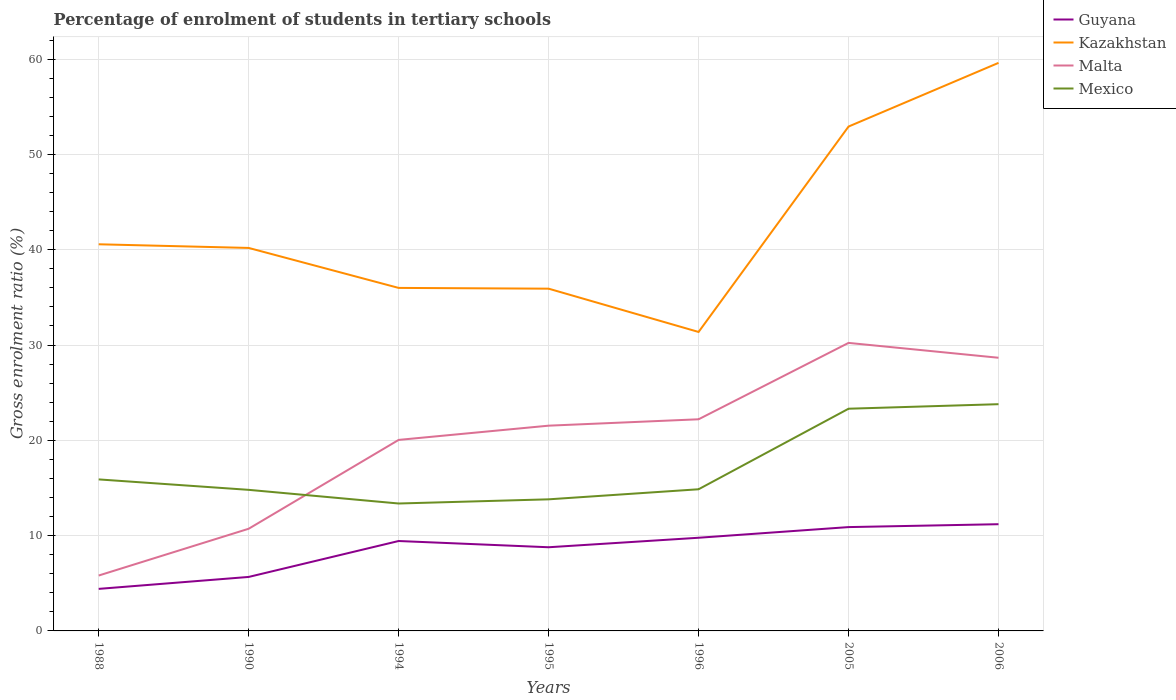Is the number of lines equal to the number of legend labels?
Your answer should be very brief. Yes. Across all years, what is the maximum percentage of students enrolled in tertiary schools in Guyana?
Offer a terse response. 4.41. In which year was the percentage of students enrolled in tertiary schools in Kazakhstan maximum?
Ensure brevity in your answer.  1996. What is the total percentage of students enrolled in tertiary schools in Guyana in the graph?
Your response must be concise. -5.53. What is the difference between the highest and the second highest percentage of students enrolled in tertiary schools in Kazakhstan?
Give a very brief answer. 28.24. What is the difference between the highest and the lowest percentage of students enrolled in tertiary schools in Malta?
Offer a very short reply. 5. How many lines are there?
Keep it short and to the point. 4. How many years are there in the graph?
Your answer should be compact. 7. Does the graph contain grids?
Your answer should be compact. Yes. What is the title of the graph?
Your answer should be very brief. Percentage of enrolment of students in tertiary schools. Does "Namibia" appear as one of the legend labels in the graph?
Your answer should be very brief. No. What is the label or title of the X-axis?
Give a very brief answer. Years. What is the label or title of the Y-axis?
Ensure brevity in your answer.  Gross enrolment ratio (%). What is the Gross enrolment ratio (%) of Guyana in 1988?
Provide a succinct answer. 4.41. What is the Gross enrolment ratio (%) in Kazakhstan in 1988?
Your answer should be compact. 40.57. What is the Gross enrolment ratio (%) in Malta in 1988?
Provide a short and direct response. 5.81. What is the Gross enrolment ratio (%) of Mexico in 1988?
Keep it short and to the point. 15.9. What is the Gross enrolment ratio (%) of Guyana in 1990?
Provide a short and direct response. 5.66. What is the Gross enrolment ratio (%) of Kazakhstan in 1990?
Your answer should be very brief. 40.19. What is the Gross enrolment ratio (%) of Malta in 1990?
Make the answer very short. 10.72. What is the Gross enrolment ratio (%) of Mexico in 1990?
Offer a very short reply. 14.8. What is the Gross enrolment ratio (%) of Guyana in 1994?
Your answer should be compact. 9.43. What is the Gross enrolment ratio (%) of Kazakhstan in 1994?
Offer a terse response. 35.99. What is the Gross enrolment ratio (%) in Malta in 1994?
Give a very brief answer. 20.04. What is the Gross enrolment ratio (%) of Mexico in 1994?
Your response must be concise. 13.37. What is the Gross enrolment ratio (%) in Guyana in 1995?
Offer a terse response. 8.78. What is the Gross enrolment ratio (%) in Kazakhstan in 1995?
Offer a terse response. 35.91. What is the Gross enrolment ratio (%) in Malta in 1995?
Make the answer very short. 21.54. What is the Gross enrolment ratio (%) of Mexico in 1995?
Provide a succinct answer. 13.81. What is the Gross enrolment ratio (%) in Guyana in 1996?
Keep it short and to the point. 9.78. What is the Gross enrolment ratio (%) of Kazakhstan in 1996?
Offer a very short reply. 31.37. What is the Gross enrolment ratio (%) of Malta in 1996?
Your answer should be very brief. 22.21. What is the Gross enrolment ratio (%) in Mexico in 1996?
Make the answer very short. 14.86. What is the Gross enrolment ratio (%) in Guyana in 2005?
Your answer should be very brief. 10.89. What is the Gross enrolment ratio (%) of Kazakhstan in 2005?
Keep it short and to the point. 52.92. What is the Gross enrolment ratio (%) in Malta in 2005?
Ensure brevity in your answer.  30.22. What is the Gross enrolment ratio (%) of Mexico in 2005?
Give a very brief answer. 23.31. What is the Gross enrolment ratio (%) of Guyana in 2006?
Provide a short and direct response. 11.2. What is the Gross enrolment ratio (%) in Kazakhstan in 2006?
Your response must be concise. 59.6. What is the Gross enrolment ratio (%) of Malta in 2006?
Make the answer very short. 28.66. What is the Gross enrolment ratio (%) in Mexico in 2006?
Give a very brief answer. 23.79. Across all years, what is the maximum Gross enrolment ratio (%) of Guyana?
Keep it short and to the point. 11.2. Across all years, what is the maximum Gross enrolment ratio (%) in Kazakhstan?
Keep it short and to the point. 59.6. Across all years, what is the maximum Gross enrolment ratio (%) in Malta?
Your response must be concise. 30.22. Across all years, what is the maximum Gross enrolment ratio (%) in Mexico?
Ensure brevity in your answer.  23.79. Across all years, what is the minimum Gross enrolment ratio (%) of Guyana?
Give a very brief answer. 4.41. Across all years, what is the minimum Gross enrolment ratio (%) of Kazakhstan?
Offer a very short reply. 31.37. Across all years, what is the minimum Gross enrolment ratio (%) in Malta?
Your response must be concise. 5.81. Across all years, what is the minimum Gross enrolment ratio (%) in Mexico?
Give a very brief answer. 13.37. What is the total Gross enrolment ratio (%) in Guyana in the graph?
Give a very brief answer. 60.16. What is the total Gross enrolment ratio (%) of Kazakhstan in the graph?
Your answer should be compact. 296.55. What is the total Gross enrolment ratio (%) in Malta in the graph?
Your response must be concise. 139.2. What is the total Gross enrolment ratio (%) in Mexico in the graph?
Your answer should be compact. 119.85. What is the difference between the Gross enrolment ratio (%) in Guyana in 1988 and that in 1990?
Ensure brevity in your answer.  -1.25. What is the difference between the Gross enrolment ratio (%) in Kazakhstan in 1988 and that in 1990?
Your response must be concise. 0.38. What is the difference between the Gross enrolment ratio (%) of Malta in 1988 and that in 1990?
Provide a short and direct response. -4.91. What is the difference between the Gross enrolment ratio (%) of Mexico in 1988 and that in 1990?
Provide a short and direct response. 1.1. What is the difference between the Gross enrolment ratio (%) of Guyana in 1988 and that in 1994?
Offer a terse response. -5.02. What is the difference between the Gross enrolment ratio (%) in Kazakhstan in 1988 and that in 1994?
Your answer should be very brief. 4.58. What is the difference between the Gross enrolment ratio (%) of Malta in 1988 and that in 1994?
Offer a terse response. -14.23. What is the difference between the Gross enrolment ratio (%) of Mexico in 1988 and that in 1994?
Keep it short and to the point. 2.53. What is the difference between the Gross enrolment ratio (%) in Guyana in 1988 and that in 1995?
Keep it short and to the point. -4.37. What is the difference between the Gross enrolment ratio (%) of Kazakhstan in 1988 and that in 1995?
Provide a succinct answer. 4.66. What is the difference between the Gross enrolment ratio (%) in Malta in 1988 and that in 1995?
Make the answer very short. -15.72. What is the difference between the Gross enrolment ratio (%) of Mexico in 1988 and that in 1995?
Provide a succinct answer. 2.09. What is the difference between the Gross enrolment ratio (%) of Guyana in 1988 and that in 1996?
Provide a short and direct response. -5.36. What is the difference between the Gross enrolment ratio (%) of Kazakhstan in 1988 and that in 1996?
Offer a very short reply. 9.2. What is the difference between the Gross enrolment ratio (%) of Malta in 1988 and that in 1996?
Offer a terse response. -16.39. What is the difference between the Gross enrolment ratio (%) in Mexico in 1988 and that in 1996?
Make the answer very short. 1.03. What is the difference between the Gross enrolment ratio (%) in Guyana in 1988 and that in 2005?
Ensure brevity in your answer.  -6.48. What is the difference between the Gross enrolment ratio (%) in Kazakhstan in 1988 and that in 2005?
Offer a very short reply. -12.35. What is the difference between the Gross enrolment ratio (%) of Malta in 1988 and that in 2005?
Your response must be concise. -24.41. What is the difference between the Gross enrolment ratio (%) of Mexico in 1988 and that in 2005?
Your answer should be compact. -7.42. What is the difference between the Gross enrolment ratio (%) of Guyana in 1988 and that in 2006?
Your response must be concise. -6.79. What is the difference between the Gross enrolment ratio (%) in Kazakhstan in 1988 and that in 2006?
Give a very brief answer. -19.04. What is the difference between the Gross enrolment ratio (%) in Malta in 1988 and that in 2006?
Ensure brevity in your answer.  -22.85. What is the difference between the Gross enrolment ratio (%) of Mexico in 1988 and that in 2006?
Ensure brevity in your answer.  -7.89. What is the difference between the Gross enrolment ratio (%) of Guyana in 1990 and that in 1994?
Your answer should be very brief. -3.77. What is the difference between the Gross enrolment ratio (%) in Kazakhstan in 1990 and that in 1994?
Keep it short and to the point. 4.2. What is the difference between the Gross enrolment ratio (%) of Malta in 1990 and that in 1994?
Your answer should be very brief. -9.32. What is the difference between the Gross enrolment ratio (%) in Mexico in 1990 and that in 1994?
Make the answer very short. 1.43. What is the difference between the Gross enrolment ratio (%) in Guyana in 1990 and that in 1995?
Provide a short and direct response. -3.11. What is the difference between the Gross enrolment ratio (%) in Kazakhstan in 1990 and that in 1995?
Offer a terse response. 4.27. What is the difference between the Gross enrolment ratio (%) of Malta in 1990 and that in 1995?
Keep it short and to the point. -10.82. What is the difference between the Gross enrolment ratio (%) in Guyana in 1990 and that in 1996?
Provide a short and direct response. -4.11. What is the difference between the Gross enrolment ratio (%) of Kazakhstan in 1990 and that in 1996?
Provide a succinct answer. 8.82. What is the difference between the Gross enrolment ratio (%) in Malta in 1990 and that in 1996?
Provide a succinct answer. -11.49. What is the difference between the Gross enrolment ratio (%) of Mexico in 1990 and that in 1996?
Keep it short and to the point. -0.06. What is the difference between the Gross enrolment ratio (%) of Guyana in 1990 and that in 2005?
Make the answer very short. -5.23. What is the difference between the Gross enrolment ratio (%) of Kazakhstan in 1990 and that in 2005?
Offer a terse response. -12.74. What is the difference between the Gross enrolment ratio (%) in Malta in 1990 and that in 2005?
Provide a short and direct response. -19.5. What is the difference between the Gross enrolment ratio (%) of Mexico in 1990 and that in 2005?
Offer a terse response. -8.51. What is the difference between the Gross enrolment ratio (%) in Guyana in 1990 and that in 2006?
Offer a very short reply. -5.53. What is the difference between the Gross enrolment ratio (%) in Kazakhstan in 1990 and that in 2006?
Offer a terse response. -19.42. What is the difference between the Gross enrolment ratio (%) of Malta in 1990 and that in 2006?
Provide a short and direct response. -17.94. What is the difference between the Gross enrolment ratio (%) of Mexico in 1990 and that in 2006?
Offer a terse response. -8.99. What is the difference between the Gross enrolment ratio (%) of Guyana in 1994 and that in 1995?
Offer a terse response. 0.65. What is the difference between the Gross enrolment ratio (%) of Kazakhstan in 1994 and that in 1995?
Your answer should be very brief. 0.08. What is the difference between the Gross enrolment ratio (%) in Malta in 1994 and that in 1995?
Make the answer very short. -1.49. What is the difference between the Gross enrolment ratio (%) of Mexico in 1994 and that in 1995?
Make the answer very short. -0.44. What is the difference between the Gross enrolment ratio (%) in Guyana in 1994 and that in 1996?
Offer a very short reply. -0.34. What is the difference between the Gross enrolment ratio (%) in Kazakhstan in 1994 and that in 1996?
Offer a very short reply. 4.62. What is the difference between the Gross enrolment ratio (%) of Malta in 1994 and that in 1996?
Keep it short and to the point. -2.16. What is the difference between the Gross enrolment ratio (%) of Mexico in 1994 and that in 1996?
Your answer should be very brief. -1.49. What is the difference between the Gross enrolment ratio (%) of Guyana in 1994 and that in 2005?
Your answer should be compact. -1.46. What is the difference between the Gross enrolment ratio (%) in Kazakhstan in 1994 and that in 2005?
Your answer should be very brief. -16.93. What is the difference between the Gross enrolment ratio (%) of Malta in 1994 and that in 2005?
Make the answer very short. -10.18. What is the difference between the Gross enrolment ratio (%) of Mexico in 1994 and that in 2005?
Your answer should be compact. -9.94. What is the difference between the Gross enrolment ratio (%) of Guyana in 1994 and that in 2006?
Your response must be concise. -1.76. What is the difference between the Gross enrolment ratio (%) in Kazakhstan in 1994 and that in 2006?
Give a very brief answer. -23.61. What is the difference between the Gross enrolment ratio (%) of Malta in 1994 and that in 2006?
Keep it short and to the point. -8.62. What is the difference between the Gross enrolment ratio (%) in Mexico in 1994 and that in 2006?
Give a very brief answer. -10.42. What is the difference between the Gross enrolment ratio (%) of Guyana in 1995 and that in 1996?
Provide a short and direct response. -1. What is the difference between the Gross enrolment ratio (%) of Kazakhstan in 1995 and that in 1996?
Make the answer very short. 4.54. What is the difference between the Gross enrolment ratio (%) in Malta in 1995 and that in 1996?
Your answer should be compact. -0.67. What is the difference between the Gross enrolment ratio (%) in Mexico in 1995 and that in 1996?
Offer a terse response. -1.06. What is the difference between the Gross enrolment ratio (%) of Guyana in 1995 and that in 2005?
Offer a terse response. -2.11. What is the difference between the Gross enrolment ratio (%) in Kazakhstan in 1995 and that in 2005?
Keep it short and to the point. -17.01. What is the difference between the Gross enrolment ratio (%) in Malta in 1995 and that in 2005?
Give a very brief answer. -8.69. What is the difference between the Gross enrolment ratio (%) of Mexico in 1995 and that in 2005?
Keep it short and to the point. -9.51. What is the difference between the Gross enrolment ratio (%) of Guyana in 1995 and that in 2006?
Your answer should be compact. -2.42. What is the difference between the Gross enrolment ratio (%) of Kazakhstan in 1995 and that in 2006?
Provide a succinct answer. -23.69. What is the difference between the Gross enrolment ratio (%) of Malta in 1995 and that in 2006?
Offer a very short reply. -7.13. What is the difference between the Gross enrolment ratio (%) in Mexico in 1995 and that in 2006?
Provide a short and direct response. -9.98. What is the difference between the Gross enrolment ratio (%) of Guyana in 1996 and that in 2005?
Provide a short and direct response. -1.12. What is the difference between the Gross enrolment ratio (%) of Kazakhstan in 1996 and that in 2005?
Provide a short and direct response. -21.55. What is the difference between the Gross enrolment ratio (%) of Malta in 1996 and that in 2005?
Offer a very short reply. -8.02. What is the difference between the Gross enrolment ratio (%) in Mexico in 1996 and that in 2005?
Ensure brevity in your answer.  -8.45. What is the difference between the Gross enrolment ratio (%) of Guyana in 1996 and that in 2006?
Provide a short and direct response. -1.42. What is the difference between the Gross enrolment ratio (%) of Kazakhstan in 1996 and that in 2006?
Offer a terse response. -28.24. What is the difference between the Gross enrolment ratio (%) in Malta in 1996 and that in 2006?
Give a very brief answer. -6.46. What is the difference between the Gross enrolment ratio (%) in Mexico in 1996 and that in 2006?
Your response must be concise. -8.93. What is the difference between the Gross enrolment ratio (%) in Guyana in 2005 and that in 2006?
Make the answer very short. -0.3. What is the difference between the Gross enrolment ratio (%) of Kazakhstan in 2005 and that in 2006?
Keep it short and to the point. -6.68. What is the difference between the Gross enrolment ratio (%) in Malta in 2005 and that in 2006?
Offer a terse response. 1.56. What is the difference between the Gross enrolment ratio (%) of Mexico in 2005 and that in 2006?
Provide a succinct answer. -0.48. What is the difference between the Gross enrolment ratio (%) of Guyana in 1988 and the Gross enrolment ratio (%) of Kazakhstan in 1990?
Offer a very short reply. -35.77. What is the difference between the Gross enrolment ratio (%) of Guyana in 1988 and the Gross enrolment ratio (%) of Malta in 1990?
Offer a very short reply. -6.31. What is the difference between the Gross enrolment ratio (%) in Guyana in 1988 and the Gross enrolment ratio (%) in Mexico in 1990?
Your answer should be very brief. -10.39. What is the difference between the Gross enrolment ratio (%) of Kazakhstan in 1988 and the Gross enrolment ratio (%) of Malta in 1990?
Keep it short and to the point. 29.85. What is the difference between the Gross enrolment ratio (%) in Kazakhstan in 1988 and the Gross enrolment ratio (%) in Mexico in 1990?
Offer a very short reply. 25.77. What is the difference between the Gross enrolment ratio (%) in Malta in 1988 and the Gross enrolment ratio (%) in Mexico in 1990?
Ensure brevity in your answer.  -8.99. What is the difference between the Gross enrolment ratio (%) of Guyana in 1988 and the Gross enrolment ratio (%) of Kazakhstan in 1994?
Make the answer very short. -31.58. What is the difference between the Gross enrolment ratio (%) in Guyana in 1988 and the Gross enrolment ratio (%) in Malta in 1994?
Your answer should be very brief. -15.63. What is the difference between the Gross enrolment ratio (%) in Guyana in 1988 and the Gross enrolment ratio (%) in Mexico in 1994?
Offer a terse response. -8.96. What is the difference between the Gross enrolment ratio (%) of Kazakhstan in 1988 and the Gross enrolment ratio (%) of Malta in 1994?
Provide a short and direct response. 20.53. What is the difference between the Gross enrolment ratio (%) in Kazakhstan in 1988 and the Gross enrolment ratio (%) in Mexico in 1994?
Ensure brevity in your answer.  27.2. What is the difference between the Gross enrolment ratio (%) in Malta in 1988 and the Gross enrolment ratio (%) in Mexico in 1994?
Your response must be concise. -7.56. What is the difference between the Gross enrolment ratio (%) of Guyana in 1988 and the Gross enrolment ratio (%) of Kazakhstan in 1995?
Offer a terse response. -31.5. What is the difference between the Gross enrolment ratio (%) in Guyana in 1988 and the Gross enrolment ratio (%) in Malta in 1995?
Ensure brevity in your answer.  -17.12. What is the difference between the Gross enrolment ratio (%) in Guyana in 1988 and the Gross enrolment ratio (%) in Mexico in 1995?
Your response must be concise. -9.4. What is the difference between the Gross enrolment ratio (%) in Kazakhstan in 1988 and the Gross enrolment ratio (%) in Malta in 1995?
Offer a terse response. 19.03. What is the difference between the Gross enrolment ratio (%) of Kazakhstan in 1988 and the Gross enrolment ratio (%) of Mexico in 1995?
Keep it short and to the point. 26.76. What is the difference between the Gross enrolment ratio (%) of Malta in 1988 and the Gross enrolment ratio (%) of Mexico in 1995?
Offer a terse response. -8. What is the difference between the Gross enrolment ratio (%) in Guyana in 1988 and the Gross enrolment ratio (%) in Kazakhstan in 1996?
Keep it short and to the point. -26.96. What is the difference between the Gross enrolment ratio (%) of Guyana in 1988 and the Gross enrolment ratio (%) of Malta in 1996?
Provide a succinct answer. -17.79. What is the difference between the Gross enrolment ratio (%) in Guyana in 1988 and the Gross enrolment ratio (%) in Mexico in 1996?
Keep it short and to the point. -10.45. What is the difference between the Gross enrolment ratio (%) in Kazakhstan in 1988 and the Gross enrolment ratio (%) in Malta in 1996?
Your answer should be compact. 18.36. What is the difference between the Gross enrolment ratio (%) in Kazakhstan in 1988 and the Gross enrolment ratio (%) in Mexico in 1996?
Make the answer very short. 25.7. What is the difference between the Gross enrolment ratio (%) of Malta in 1988 and the Gross enrolment ratio (%) of Mexico in 1996?
Your answer should be very brief. -9.05. What is the difference between the Gross enrolment ratio (%) in Guyana in 1988 and the Gross enrolment ratio (%) in Kazakhstan in 2005?
Keep it short and to the point. -48.51. What is the difference between the Gross enrolment ratio (%) of Guyana in 1988 and the Gross enrolment ratio (%) of Malta in 2005?
Offer a terse response. -25.81. What is the difference between the Gross enrolment ratio (%) in Guyana in 1988 and the Gross enrolment ratio (%) in Mexico in 2005?
Provide a succinct answer. -18.9. What is the difference between the Gross enrolment ratio (%) in Kazakhstan in 1988 and the Gross enrolment ratio (%) in Malta in 2005?
Offer a very short reply. 10.35. What is the difference between the Gross enrolment ratio (%) in Kazakhstan in 1988 and the Gross enrolment ratio (%) in Mexico in 2005?
Your response must be concise. 17.25. What is the difference between the Gross enrolment ratio (%) of Malta in 1988 and the Gross enrolment ratio (%) of Mexico in 2005?
Offer a very short reply. -17.5. What is the difference between the Gross enrolment ratio (%) in Guyana in 1988 and the Gross enrolment ratio (%) in Kazakhstan in 2006?
Make the answer very short. -55.19. What is the difference between the Gross enrolment ratio (%) of Guyana in 1988 and the Gross enrolment ratio (%) of Malta in 2006?
Provide a succinct answer. -24.25. What is the difference between the Gross enrolment ratio (%) in Guyana in 1988 and the Gross enrolment ratio (%) in Mexico in 2006?
Your answer should be very brief. -19.38. What is the difference between the Gross enrolment ratio (%) of Kazakhstan in 1988 and the Gross enrolment ratio (%) of Malta in 2006?
Your answer should be compact. 11.91. What is the difference between the Gross enrolment ratio (%) of Kazakhstan in 1988 and the Gross enrolment ratio (%) of Mexico in 2006?
Make the answer very short. 16.78. What is the difference between the Gross enrolment ratio (%) in Malta in 1988 and the Gross enrolment ratio (%) in Mexico in 2006?
Your answer should be compact. -17.98. What is the difference between the Gross enrolment ratio (%) of Guyana in 1990 and the Gross enrolment ratio (%) of Kazakhstan in 1994?
Your answer should be compact. -30.33. What is the difference between the Gross enrolment ratio (%) of Guyana in 1990 and the Gross enrolment ratio (%) of Malta in 1994?
Offer a very short reply. -14.38. What is the difference between the Gross enrolment ratio (%) in Guyana in 1990 and the Gross enrolment ratio (%) in Mexico in 1994?
Your response must be concise. -7.71. What is the difference between the Gross enrolment ratio (%) of Kazakhstan in 1990 and the Gross enrolment ratio (%) of Malta in 1994?
Your response must be concise. 20.14. What is the difference between the Gross enrolment ratio (%) of Kazakhstan in 1990 and the Gross enrolment ratio (%) of Mexico in 1994?
Keep it short and to the point. 26.82. What is the difference between the Gross enrolment ratio (%) in Malta in 1990 and the Gross enrolment ratio (%) in Mexico in 1994?
Provide a short and direct response. -2.65. What is the difference between the Gross enrolment ratio (%) in Guyana in 1990 and the Gross enrolment ratio (%) in Kazakhstan in 1995?
Offer a very short reply. -30.25. What is the difference between the Gross enrolment ratio (%) of Guyana in 1990 and the Gross enrolment ratio (%) of Malta in 1995?
Offer a very short reply. -15.87. What is the difference between the Gross enrolment ratio (%) of Guyana in 1990 and the Gross enrolment ratio (%) of Mexico in 1995?
Make the answer very short. -8.14. What is the difference between the Gross enrolment ratio (%) in Kazakhstan in 1990 and the Gross enrolment ratio (%) in Malta in 1995?
Your response must be concise. 18.65. What is the difference between the Gross enrolment ratio (%) in Kazakhstan in 1990 and the Gross enrolment ratio (%) in Mexico in 1995?
Offer a terse response. 26.38. What is the difference between the Gross enrolment ratio (%) of Malta in 1990 and the Gross enrolment ratio (%) of Mexico in 1995?
Your answer should be very brief. -3.09. What is the difference between the Gross enrolment ratio (%) of Guyana in 1990 and the Gross enrolment ratio (%) of Kazakhstan in 1996?
Your answer should be very brief. -25.7. What is the difference between the Gross enrolment ratio (%) in Guyana in 1990 and the Gross enrolment ratio (%) in Malta in 1996?
Your response must be concise. -16.54. What is the difference between the Gross enrolment ratio (%) in Guyana in 1990 and the Gross enrolment ratio (%) in Mexico in 1996?
Offer a terse response. -9.2. What is the difference between the Gross enrolment ratio (%) of Kazakhstan in 1990 and the Gross enrolment ratio (%) of Malta in 1996?
Your response must be concise. 17.98. What is the difference between the Gross enrolment ratio (%) of Kazakhstan in 1990 and the Gross enrolment ratio (%) of Mexico in 1996?
Offer a very short reply. 25.32. What is the difference between the Gross enrolment ratio (%) of Malta in 1990 and the Gross enrolment ratio (%) of Mexico in 1996?
Provide a succinct answer. -4.14. What is the difference between the Gross enrolment ratio (%) in Guyana in 1990 and the Gross enrolment ratio (%) in Kazakhstan in 2005?
Make the answer very short. -47.26. What is the difference between the Gross enrolment ratio (%) of Guyana in 1990 and the Gross enrolment ratio (%) of Malta in 2005?
Your response must be concise. -24.56. What is the difference between the Gross enrolment ratio (%) of Guyana in 1990 and the Gross enrolment ratio (%) of Mexico in 2005?
Provide a succinct answer. -17.65. What is the difference between the Gross enrolment ratio (%) in Kazakhstan in 1990 and the Gross enrolment ratio (%) in Malta in 2005?
Give a very brief answer. 9.96. What is the difference between the Gross enrolment ratio (%) of Kazakhstan in 1990 and the Gross enrolment ratio (%) of Mexico in 2005?
Provide a short and direct response. 16.87. What is the difference between the Gross enrolment ratio (%) in Malta in 1990 and the Gross enrolment ratio (%) in Mexico in 2005?
Ensure brevity in your answer.  -12.59. What is the difference between the Gross enrolment ratio (%) in Guyana in 1990 and the Gross enrolment ratio (%) in Kazakhstan in 2006?
Provide a succinct answer. -53.94. What is the difference between the Gross enrolment ratio (%) of Guyana in 1990 and the Gross enrolment ratio (%) of Malta in 2006?
Keep it short and to the point. -23. What is the difference between the Gross enrolment ratio (%) of Guyana in 1990 and the Gross enrolment ratio (%) of Mexico in 2006?
Provide a succinct answer. -18.13. What is the difference between the Gross enrolment ratio (%) of Kazakhstan in 1990 and the Gross enrolment ratio (%) of Malta in 2006?
Make the answer very short. 11.52. What is the difference between the Gross enrolment ratio (%) in Kazakhstan in 1990 and the Gross enrolment ratio (%) in Mexico in 2006?
Your response must be concise. 16.4. What is the difference between the Gross enrolment ratio (%) of Malta in 1990 and the Gross enrolment ratio (%) of Mexico in 2006?
Your answer should be very brief. -13.07. What is the difference between the Gross enrolment ratio (%) in Guyana in 1994 and the Gross enrolment ratio (%) in Kazakhstan in 1995?
Offer a very short reply. -26.48. What is the difference between the Gross enrolment ratio (%) in Guyana in 1994 and the Gross enrolment ratio (%) in Malta in 1995?
Make the answer very short. -12.1. What is the difference between the Gross enrolment ratio (%) in Guyana in 1994 and the Gross enrolment ratio (%) in Mexico in 1995?
Your answer should be compact. -4.37. What is the difference between the Gross enrolment ratio (%) of Kazakhstan in 1994 and the Gross enrolment ratio (%) of Malta in 1995?
Your response must be concise. 14.45. What is the difference between the Gross enrolment ratio (%) in Kazakhstan in 1994 and the Gross enrolment ratio (%) in Mexico in 1995?
Offer a very short reply. 22.18. What is the difference between the Gross enrolment ratio (%) in Malta in 1994 and the Gross enrolment ratio (%) in Mexico in 1995?
Provide a short and direct response. 6.23. What is the difference between the Gross enrolment ratio (%) in Guyana in 1994 and the Gross enrolment ratio (%) in Kazakhstan in 1996?
Keep it short and to the point. -21.93. What is the difference between the Gross enrolment ratio (%) in Guyana in 1994 and the Gross enrolment ratio (%) in Malta in 1996?
Your answer should be very brief. -12.77. What is the difference between the Gross enrolment ratio (%) in Guyana in 1994 and the Gross enrolment ratio (%) in Mexico in 1996?
Provide a succinct answer. -5.43. What is the difference between the Gross enrolment ratio (%) in Kazakhstan in 1994 and the Gross enrolment ratio (%) in Malta in 1996?
Keep it short and to the point. 13.78. What is the difference between the Gross enrolment ratio (%) in Kazakhstan in 1994 and the Gross enrolment ratio (%) in Mexico in 1996?
Keep it short and to the point. 21.13. What is the difference between the Gross enrolment ratio (%) of Malta in 1994 and the Gross enrolment ratio (%) of Mexico in 1996?
Make the answer very short. 5.18. What is the difference between the Gross enrolment ratio (%) in Guyana in 1994 and the Gross enrolment ratio (%) in Kazakhstan in 2005?
Keep it short and to the point. -43.49. What is the difference between the Gross enrolment ratio (%) of Guyana in 1994 and the Gross enrolment ratio (%) of Malta in 2005?
Provide a succinct answer. -20.79. What is the difference between the Gross enrolment ratio (%) of Guyana in 1994 and the Gross enrolment ratio (%) of Mexico in 2005?
Ensure brevity in your answer.  -13.88. What is the difference between the Gross enrolment ratio (%) of Kazakhstan in 1994 and the Gross enrolment ratio (%) of Malta in 2005?
Make the answer very short. 5.77. What is the difference between the Gross enrolment ratio (%) in Kazakhstan in 1994 and the Gross enrolment ratio (%) in Mexico in 2005?
Your answer should be compact. 12.68. What is the difference between the Gross enrolment ratio (%) of Malta in 1994 and the Gross enrolment ratio (%) of Mexico in 2005?
Your answer should be very brief. -3.27. What is the difference between the Gross enrolment ratio (%) in Guyana in 1994 and the Gross enrolment ratio (%) in Kazakhstan in 2006?
Your answer should be compact. -50.17. What is the difference between the Gross enrolment ratio (%) in Guyana in 1994 and the Gross enrolment ratio (%) in Malta in 2006?
Offer a terse response. -19.23. What is the difference between the Gross enrolment ratio (%) in Guyana in 1994 and the Gross enrolment ratio (%) in Mexico in 2006?
Give a very brief answer. -14.36. What is the difference between the Gross enrolment ratio (%) in Kazakhstan in 1994 and the Gross enrolment ratio (%) in Malta in 2006?
Your response must be concise. 7.33. What is the difference between the Gross enrolment ratio (%) in Kazakhstan in 1994 and the Gross enrolment ratio (%) in Mexico in 2006?
Your answer should be very brief. 12.2. What is the difference between the Gross enrolment ratio (%) in Malta in 1994 and the Gross enrolment ratio (%) in Mexico in 2006?
Keep it short and to the point. -3.75. What is the difference between the Gross enrolment ratio (%) in Guyana in 1995 and the Gross enrolment ratio (%) in Kazakhstan in 1996?
Offer a very short reply. -22.59. What is the difference between the Gross enrolment ratio (%) in Guyana in 1995 and the Gross enrolment ratio (%) in Malta in 1996?
Offer a terse response. -13.43. What is the difference between the Gross enrolment ratio (%) of Guyana in 1995 and the Gross enrolment ratio (%) of Mexico in 1996?
Offer a very short reply. -6.08. What is the difference between the Gross enrolment ratio (%) in Kazakhstan in 1995 and the Gross enrolment ratio (%) in Malta in 1996?
Keep it short and to the point. 13.71. What is the difference between the Gross enrolment ratio (%) of Kazakhstan in 1995 and the Gross enrolment ratio (%) of Mexico in 1996?
Offer a terse response. 21.05. What is the difference between the Gross enrolment ratio (%) of Malta in 1995 and the Gross enrolment ratio (%) of Mexico in 1996?
Provide a short and direct response. 6.67. What is the difference between the Gross enrolment ratio (%) in Guyana in 1995 and the Gross enrolment ratio (%) in Kazakhstan in 2005?
Make the answer very short. -44.14. What is the difference between the Gross enrolment ratio (%) in Guyana in 1995 and the Gross enrolment ratio (%) in Malta in 2005?
Offer a terse response. -21.44. What is the difference between the Gross enrolment ratio (%) in Guyana in 1995 and the Gross enrolment ratio (%) in Mexico in 2005?
Your answer should be very brief. -14.54. What is the difference between the Gross enrolment ratio (%) of Kazakhstan in 1995 and the Gross enrolment ratio (%) of Malta in 2005?
Keep it short and to the point. 5.69. What is the difference between the Gross enrolment ratio (%) in Kazakhstan in 1995 and the Gross enrolment ratio (%) in Mexico in 2005?
Ensure brevity in your answer.  12.6. What is the difference between the Gross enrolment ratio (%) of Malta in 1995 and the Gross enrolment ratio (%) of Mexico in 2005?
Make the answer very short. -1.78. What is the difference between the Gross enrolment ratio (%) of Guyana in 1995 and the Gross enrolment ratio (%) of Kazakhstan in 2006?
Offer a very short reply. -50.82. What is the difference between the Gross enrolment ratio (%) in Guyana in 1995 and the Gross enrolment ratio (%) in Malta in 2006?
Offer a very short reply. -19.88. What is the difference between the Gross enrolment ratio (%) of Guyana in 1995 and the Gross enrolment ratio (%) of Mexico in 2006?
Keep it short and to the point. -15.01. What is the difference between the Gross enrolment ratio (%) of Kazakhstan in 1995 and the Gross enrolment ratio (%) of Malta in 2006?
Ensure brevity in your answer.  7.25. What is the difference between the Gross enrolment ratio (%) of Kazakhstan in 1995 and the Gross enrolment ratio (%) of Mexico in 2006?
Your response must be concise. 12.12. What is the difference between the Gross enrolment ratio (%) of Malta in 1995 and the Gross enrolment ratio (%) of Mexico in 2006?
Offer a terse response. -2.25. What is the difference between the Gross enrolment ratio (%) of Guyana in 1996 and the Gross enrolment ratio (%) of Kazakhstan in 2005?
Keep it short and to the point. -43.15. What is the difference between the Gross enrolment ratio (%) of Guyana in 1996 and the Gross enrolment ratio (%) of Malta in 2005?
Make the answer very short. -20.45. What is the difference between the Gross enrolment ratio (%) in Guyana in 1996 and the Gross enrolment ratio (%) in Mexico in 2005?
Make the answer very short. -13.54. What is the difference between the Gross enrolment ratio (%) of Kazakhstan in 1996 and the Gross enrolment ratio (%) of Malta in 2005?
Offer a very short reply. 1.15. What is the difference between the Gross enrolment ratio (%) in Kazakhstan in 1996 and the Gross enrolment ratio (%) in Mexico in 2005?
Ensure brevity in your answer.  8.05. What is the difference between the Gross enrolment ratio (%) of Malta in 1996 and the Gross enrolment ratio (%) of Mexico in 2005?
Provide a short and direct response. -1.11. What is the difference between the Gross enrolment ratio (%) in Guyana in 1996 and the Gross enrolment ratio (%) in Kazakhstan in 2006?
Give a very brief answer. -49.83. What is the difference between the Gross enrolment ratio (%) in Guyana in 1996 and the Gross enrolment ratio (%) in Malta in 2006?
Your response must be concise. -18.89. What is the difference between the Gross enrolment ratio (%) in Guyana in 1996 and the Gross enrolment ratio (%) in Mexico in 2006?
Your answer should be compact. -14.01. What is the difference between the Gross enrolment ratio (%) of Kazakhstan in 1996 and the Gross enrolment ratio (%) of Malta in 2006?
Ensure brevity in your answer.  2.71. What is the difference between the Gross enrolment ratio (%) of Kazakhstan in 1996 and the Gross enrolment ratio (%) of Mexico in 2006?
Your response must be concise. 7.58. What is the difference between the Gross enrolment ratio (%) in Malta in 1996 and the Gross enrolment ratio (%) in Mexico in 2006?
Your response must be concise. -1.58. What is the difference between the Gross enrolment ratio (%) of Guyana in 2005 and the Gross enrolment ratio (%) of Kazakhstan in 2006?
Keep it short and to the point. -48.71. What is the difference between the Gross enrolment ratio (%) of Guyana in 2005 and the Gross enrolment ratio (%) of Malta in 2006?
Offer a terse response. -17.77. What is the difference between the Gross enrolment ratio (%) of Guyana in 2005 and the Gross enrolment ratio (%) of Mexico in 2006?
Offer a terse response. -12.9. What is the difference between the Gross enrolment ratio (%) of Kazakhstan in 2005 and the Gross enrolment ratio (%) of Malta in 2006?
Make the answer very short. 24.26. What is the difference between the Gross enrolment ratio (%) of Kazakhstan in 2005 and the Gross enrolment ratio (%) of Mexico in 2006?
Give a very brief answer. 29.13. What is the difference between the Gross enrolment ratio (%) in Malta in 2005 and the Gross enrolment ratio (%) in Mexico in 2006?
Your answer should be compact. 6.43. What is the average Gross enrolment ratio (%) in Guyana per year?
Give a very brief answer. 8.59. What is the average Gross enrolment ratio (%) in Kazakhstan per year?
Provide a succinct answer. 42.36. What is the average Gross enrolment ratio (%) of Malta per year?
Ensure brevity in your answer.  19.89. What is the average Gross enrolment ratio (%) of Mexico per year?
Provide a succinct answer. 17.12. In the year 1988, what is the difference between the Gross enrolment ratio (%) of Guyana and Gross enrolment ratio (%) of Kazakhstan?
Provide a succinct answer. -36.16. In the year 1988, what is the difference between the Gross enrolment ratio (%) in Guyana and Gross enrolment ratio (%) in Malta?
Give a very brief answer. -1.4. In the year 1988, what is the difference between the Gross enrolment ratio (%) in Guyana and Gross enrolment ratio (%) in Mexico?
Provide a short and direct response. -11.49. In the year 1988, what is the difference between the Gross enrolment ratio (%) in Kazakhstan and Gross enrolment ratio (%) in Malta?
Keep it short and to the point. 34.76. In the year 1988, what is the difference between the Gross enrolment ratio (%) of Kazakhstan and Gross enrolment ratio (%) of Mexico?
Offer a very short reply. 24.67. In the year 1988, what is the difference between the Gross enrolment ratio (%) in Malta and Gross enrolment ratio (%) in Mexico?
Provide a succinct answer. -10.09. In the year 1990, what is the difference between the Gross enrolment ratio (%) in Guyana and Gross enrolment ratio (%) in Kazakhstan?
Ensure brevity in your answer.  -34.52. In the year 1990, what is the difference between the Gross enrolment ratio (%) of Guyana and Gross enrolment ratio (%) of Malta?
Ensure brevity in your answer.  -5.06. In the year 1990, what is the difference between the Gross enrolment ratio (%) in Guyana and Gross enrolment ratio (%) in Mexico?
Ensure brevity in your answer.  -9.14. In the year 1990, what is the difference between the Gross enrolment ratio (%) of Kazakhstan and Gross enrolment ratio (%) of Malta?
Offer a terse response. 29.47. In the year 1990, what is the difference between the Gross enrolment ratio (%) of Kazakhstan and Gross enrolment ratio (%) of Mexico?
Your answer should be compact. 25.38. In the year 1990, what is the difference between the Gross enrolment ratio (%) in Malta and Gross enrolment ratio (%) in Mexico?
Your answer should be very brief. -4.08. In the year 1994, what is the difference between the Gross enrolment ratio (%) of Guyana and Gross enrolment ratio (%) of Kazakhstan?
Offer a very short reply. -26.56. In the year 1994, what is the difference between the Gross enrolment ratio (%) in Guyana and Gross enrolment ratio (%) in Malta?
Provide a succinct answer. -10.61. In the year 1994, what is the difference between the Gross enrolment ratio (%) of Guyana and Gross enrolment ratio (%) of Mexico?
Provide a short and direct response. -3.94. In the year 1994, what is the difference between the Gross enrolment ratio (%) of Kazakhstan and Gross enrolment ratio (%) of Malta?
Make the answer very short. 15.95. In the year 1994, what is the difference between the Gross enrolment ratio (%) of Kazakhstan and Gross enrolment ratio (%) of Mexico?
Your answer should be very brief. 22.62. In the year 1994, what is the difference between the Gross enrolment ratio (%) in Malta and Gross enrolment ratio (%) in Mexico?
Provide a short and direct response. 6.67. In the year 1995, what is the difference between the Gross enrolment ratio (%) of Guyana and Gross enrolment ratio (%) of Kazakhstan?
Keep it short and to the point. -27.13. In the year 1995, what is the difference between the Gross enrolment ratio (%) of Guyana and Gross enrolment ratio (%) of Malta?
Offer a very short reply. -12.76. In the year 1995, what is the difference between the Gross enrolment ratio (%) of Guyana and Gross enrolment ratio (%) of Mexico?
Provide a succinct answer. -5.03. In the year 1995, what is the difference between the Gross enrolment ratio (%) of Kazakhstan and Gross enrolment ratio (%) of Malta?
Your response must be concise. 14.38. In the year 1995, what is the difference between the Gross enrolment ratio (%) of Kazakhstan and Gross enrolment ratio (%) of Mexico?
Provide a short and direct response. 22.1. In the year 1995, what is the difference between the Gross enrolment ratio (%) in Malta and Gross enrolment ratio (%) in Mexico?
Your answer should be very brief. 7.73. In the year 1996, what is the difference between the Gross enrolment ratio (%) of Guyana and Gross enrolment ratio (%) of Kazakhstan?
Provide a short and direct response. -21.59. In the year 1996, what is the difference between the Gross enrolment ratio (%) in Guyana and Gross enrolment ratio (%) in Malta?
Make the answer very short. -12.43. In the year 1996, what is the difference between the Gross enrolment ratio (%) in Guyana and Gross enrolment ratio (%) in Mexico?
Your response must be concise. -5.09. In the year 1996, what is the difference between the Gross enrolment ratio (%) in Kazakhstan and Gross enrolment ratio (%) in Malta?
Ensure brevity in your answer.  9.16. In the year 1996, what is the difference between the Gross enrolment ratio (%) of Kazakhstan and Gross enrolment ratio (%) of Mexico?
Make the answer very short. 16.51. In the year 1996, what is the difference between the Gross enrolment ratio (%) in Malta and Gross enrolment ratio (%) in Mexico?
Make the answer very short. 7.34. In the year 2005, what is the difference between the Gross enrolment ratio (%) of Guyana and Gross enrolment ratio (%) of Kazakhstan?
Offer a terse response. -42.03. In the year 2005, what is the difference between the Gross enrolment ratio (%) in Guyana and Gross enrolment ratio (%) in Malta?
Ensure brevity in your answer.  -19.33. In the year 2005, what is the difference between the Gross enrolment ratio (%) of Guyana and Gross enrolment ratio (%) of Mexico?
Offer a terse response. -12.42. In the year 2005, what is the difference between the Gross enrolment ratio (%) in Kazakhstan and Gross enrolment ratio (%) in Malta?
Provide a short and direct response. 22.7. In the year 2005, what is the difference between the Gross enrolment ratio (%) of Kazakhstan and Gross enrolment ratio (%) of Mexico?
Make the answer very short. 29.61. In the year 2005, what is the difference between the Gross enrolment ratio (%) in Malta and Gross enrolment ratio (%) in Mexico?
Offer a very short reply. 6.91. In the year 2006, what is the difference between the Gross enrolment ratio (%) in Guyana and Gross enrolment ratio (%) in Kazakhstan?
Ensure brevity in your answer.  -48.41. In the year 2006, what is the difference between the Gross enrolment ratio (%) in Guyana and Gross enrolment ratio (%) in Malta?
Offer a terse response. -17.46. In the year 2006, what is the difference between the Gross enrolment ratio (%) in Guyana and Gross enrolment ratio (%) in Mexico?
Keep it short and to the point. -12.59. In the year 2006, what is the difference between the Gross enrolment ratio (%) in Kazakhstan and Gross enrolment ratio (%) in Malta?
Your response must be concise. 30.94. In the year 2006, what is the difference between the Gross enrolment ratio (%) of Kazakhstan and Gross enrolment ratio (%) of Mexico?
Provide a short and direct response. 35.81. In the year 2006, what is the difference between the Gross enrolment ratio (%) of Malta and Gross enrolment ratio (%) of Mexico?
Offer a very short reply. 4.87. What is the ratio of the Gross enrolment ratio (%) in Guyana in 1988 to that in 1990?
Give a very brief answer. 0.78. What is the ratio of the Gross enrolment ratio (%) of Kazakhstan in 1988 to that in 1990?
Give a very brief answer. 1.01. What is the ratio of the Gross enrolment ratio (%) of Malta in 1988 to that in 1990?
Give a very brief answer. 0.54. What is the ratio of the Gross enrolment ratio (%) in Mexico in 1988 to that in 1990?
Give a very brief answer. 1.07. What is the ratio of the Gross enrolment ratio (%) of Guyana in 1988 to that in 1994?
Give a very brief answer. 0.47. What is the ratio of the Gross enrolment ratio (%) of Kazakhstan in 1988 to that in 1994?
Provide a succinct answer. 1.13. What is the ratio of the Gross enrolment ratio (%) in Malta in 1988 to that in 1994?
Ensure brevity in your answer.  0.29. What is the ratio of the Gross enrolment ratio (%) of Mexico in 1988 to that in 1994?
Give a very brief answer. 1.19. What is the ratio of the Gross enrolment ratio (%) of Guyana in 1988 to that in 1995?
Ensure brevity in your answer.  0.5. What is the ratio of the Gross enrolment ratio (%) in Kazakhstan in 1988 to that in 1995?
Keep it short and to the point. 1.13. What is the ratio of the Gross enrolment ratio (%) in Malta in 1988 to that in 1995?
Provide a short and direct response. 0.27. What is the ratio of the Gross enrolment ratio (%) of Mexico in 1988 to that in 1995?
Offer a terse response. 1.15. What is the ratio of the Gross enrolment ratio (%) of Guyana in 1988 to that in 1996?
Keep it short and to the point. 0.45. What is the ratio of the Gross enrolment ratio (%) of Kazakhstan in 1988 to that in 1996?
Your answer should be very brief. 1.29. What is the ratio of the Gross enrolment ratio (%) of Malta in 1988 to that in 1996?
Ensure brevity in your answer.  0.26. What is the ratio of the Gross enrolment ratio (%) in Mexico in 1988 to that in 1996?
Ensure brevity in your answer.  1.07. What is the ratio of the Gross enrolment ratio (%) of Guyana in 1988 to that in 2005?
Offer a terse response. 0.41. What is the ratio of the Gross enrolment ratio (%) of Kazakhstan in 1988 to that in 2005?
Your response must be concise. 0.77. What is the ratio of the Gross enrolment ratio (%) in Malta in 1988 to that in 2005?
Give a very brief answer. 0.19. What is the ratio of the Gross enrolment ratio (%) in Mexico in 1988 to that in 2005?
Your response must be concise. 0.68. What is the ratio of the Gross enrolment ratio (%) in Guyana in 1988 to that in 2006?
Provide a short and direct response. 0.39. What is the ratio of the Gross enrolment ratio (%) in Kazakhstan in 1988 to that in 2006?
Keep it short and to the point. 0.68. What is the ratio of the Gross enrolment ratio (%) in Malta in 1988 to that in 2006?
Keep it short and to the point. 0.2. What is the ratio of the Gross enrolment ratio (%) in Mexico in 1988 to that in 2006?
Offer a very short reply. 0.67. What is the ratio of the Gross enrolment ratio (%) of Guyana in 1990 to that in 1994?
Your answer should be very brief. 0.6. What is the ratio of the Gross enrolment ratio (%) of Kazakhstan in 1990 to that in 1994?
Your answer should be compact. 1.12. What is the ratio of the Gross enrolment ratio (%) of Malta in 1990 to that in 1994?
Make the answer very short. 0.53. What is the ratio of the Gross enrolment ratio (%) in Mexico in 1990 to that in 1994?
Your answer should be very brief. 1.11. What is the ratio of the Gross enrolment ratio (%) in Guyana in 1990 to that in 1995?
Your answer should be very brief. 0.65. What is the ratio of the Gross enrolment ratio (%) in Kazakhstan in 1990 to that in 1995?
Provide a succinct answer. 1.12. What is the ratio of the Gross enrolment ratio (%) in Malta in 1990 to that in 1995?
Your answer should be compact. 0.5. What is the ratio of the Gross enrolment ratio (%) of Mexico in 1990 to that in 1995?
Provide a short and direct response. 1.07. What is the ratio of the Gross enrolment ratio (%) in Guyana in 1990 to that in 1996?
Provide a succinct answer. 0.58. What is the ratio of the Gross enrolment ratio (%) in Kazakhstan in 1990 to that in 1996?
Ensure brevity in your answer.  1.28. What is the ratio of the Gross enrolment ratio (%) in Malta in 1990 to that in 1996?
Your answer should be very brief. 0.48. What is the ratio of the Gross enrolment ratio (%) of Guyana in 1990 to that in 2005?
Your answer should be compact. 0.52. What is the ratio of the Gross enrolment ratio (%) of Kazakhstan in 1990 to that in 2005?
Keep it short and to the point. 0.76. What is the ratio of the Gross enrolment ratio (%) of Malta in 1990 to that in 2005?
Your answer should be compact. 0.35. What is the ratio of the Gross enrolment ratio (%) in Mexico in 1990 to that in 2005?
Offer a terse response. 0.63. What is the ratio of the Gross enrolment ratio (%) in Guyana in 1990 to that in 2006?
Your response must be concise. 0.51. What is the ratio of the Gross enrolment ratio (%) in Kazakhstan in 1990 to that in 2006?
Ensure brevity in your answer.  0.67. What is the ratio of the Gross enrolment ratio (%) in Malta in 1990 to that in 2006?
Your answer should be compact. 0.37. What is the ratio of the Gross enrolment ratio (%) in Mexico in 1990 to that in 2006?
Make the answer very short. 0.62. What is the ratio of the Gross enrolment ratio (%) of Guyana in 1994 to that in 1995?
Ensure brevity in your answer.  1.07. What is the ratio of the Gross enrolment ratio (%) in Kazakhstan in 1994 to that in 1995?
Your answer should be compact. 1. What is the ratio of the Gross enrolment ratio (%) of Malta in 1994 to that in 1995?
Offer a terse response. 0.93. What is the ratio of the Gross enrolment ratio (%) of Mexico in 1994 to that in 1995?
Your answer should be compact. 0.97. What is the ratio of the Gross enrolment ratio (%) of Kazakhstan in 1994 to that in 1996?
Your answer should be compact. 1.15. What is the ratio of the Gross enrolment ratio (%) in Malta in 1994 to that in 1996?
Your answer should be compact. 0.9. What is the ratio of the Gross enrolment ratio (%) in Mexico in 1994 to that in 1996?
Offer a terse response. 0.9. What is the ratio of the Gross enrolment ratio (%) in Guyana in 1994 to that in 2005?
Provide a succinct answer. 0.87. What is the ratio of the Gross enrolment ratio (%) of Kazakhstan in 1994 to that in 2005?
Offer a very short reply. 0.68. What is the ratio of the Gross enrolment ratio (%) in Malta in 1994 to that in 2005?
Ensure brevity in your answer.  0.66. What is the ratio of the Gross enrolment ratio (%) in Mexico in 1994 to that in 2005?
Make the answer very short. 0.57. What is the ratio of the Gross enrolment ratio (%) of Guyana in 1994 to that in 2006?
Offer a terse response. 0.84. What is the ratio of the Gross enrolment ratio (%) in Kazakhstan in 1994 to that in 2006?
Offer a terse response. 0.6. What is the ratio of the Gross enrolment ratio (%) in Malta in 1994 to that in 2006?
Your answer should be compact. 0.7. What is the ratio of the Gross enrolment ratio (%) of Mexico in 1994 to that in 2006?
Your answer should be very brief. 0.56. What is the ratio of the Gross enrolment ratio (%) in Guyana in 1995 to that in 1996?
Your response must be concise. 0.9. What is the ratio of the Gross enrolment ratio (%) in Kazakhstan in 1995 to that in 1996?
Your answer should be very brief. 1.14. What is the ratio of the Gross enrolment ratio (%) in Malta in 1995 to that in 1996?
Offer a terse response. 0.97. What is the ratio of the Gross enrolment ratio (%) in Mexico in 1995 to that in 1996?
Provide a short and direct response. 0.93. What is the ratio of the Gross enrolment ratio (%) in Guyana in 1995 to that in 2005?
Give a very brief answer. 0.81. What is the ratio of the Gross enrolment ratio (%) of Kazakhstan in 1995 to that in 2005?
Offer a very short reply. 0.68. What is the ratio of the Gross enrolment ratio (%) of Malta in 1995 to that in 2005?
Ensure brevity in your answer.  0.71. What is the ratio of the Gross enrolment ratio (%) in Mexico in 1995 to that in 2005?
Ensure brevity in your answer.  0.59. What is the ratio of the Gross enrolment ratio (%) in Guyana in 1995 to that in 2006?
Give a very brief answer. 0.78. What is the ratio of the Gross enrolment ratio (%) in Kazakhstan in 1995 to that in 2006?
Provide a succinct answer. 0.6. What is the ratio of the Gross enrolment ratio (%) of Malta in 1995 to that in 2006?
Make the answer very short. 0.75. What is the ratio of the Gross enrolment ratio (%) in Mexico in 1995 to that in 2006?
Make the answer very short. 0.58. What is the ratio of the Gross enrolment ratio (%) of Guyana in 1996 to that in 2005?
Your answer should be very brief. 0.9. What is the ratio of the Gross enrolment ratio (%) in Kazakhstan in 1996 to that in 2005?
Keep it short and to the point. 0.59. What is the ratio of the Gross enrolment ratio (%) of Malta in 1996 to that in 2005?
Provide a succinct answer. 0.73. What is the ratio of the Gross enrolment ratio (%) in Mexico in 1996 to that in 2005?
Make the answer very short. 0.64. What is the ratio of the Gross enrolment ratio (%) in Guyana in 1996 to that in 2006?
Your answer should be compact. 0.87. What is the ratio of the Gross enrolment ratio (%) in Kazakhstan in 1996 to that in 2006?
Your response must be concise. 0.53. What is the ratio of the Gross enrolment ratio (%) of Malta in 1996 to that in 2006?
Keep it short and to the point. 0.77. What is the ratio of the Gross enrolment ratio (%) in Mexico in 1996 to that in 2006?
Offer a terse response. 0.62. What is the ratio of the Gross enrolment ratio (%) of Guyana in 2005 to that in 2006?
Provide a short and direct response. 0.97. What is the ratio of the Gross enrolment ratio (%) in Kazakhstan in 2005 to that in 2006?
Your response must be concise. 0.89. What is the ratio of the Gross enrolment ratio (%) in Malta in 2005 to that in 2006?
Your response must be concise. 1.05. What is the difference between the highest and the second highest Gross enrolment ratio (%) of Guyana?
Your answer should be compact. 0.3. What is the difference between the highest and the second highest Gross enrolment ratio (%) in Kazakhstan?
Keep it short and to the point. 6.68. What is the difference between the highest and the second highest Gross enrolment ratio (%) of Malta?
Give a very brief answer. 1.56. What is the difference between the highest and the second highest Gross enrolment ratio (%) of Mexico?
Offer a very short reply. 0.48. What is the difference between the highest and the lowest Gross enrolment ratio (%) of Guyana?
Give a very brief answer. 6.79. What is the difference between the highest and the lowest Gross enrolment ratio (%) in Kazakhstan?
Your answer should be very brief. 28.24. What is the difference between the highest and the lowest Gross enrolment ratio (%) of Malta?
Offer a terse response. 24.41. What is the difference between the highest and the lowest Gross enrolment ratio (%) of Mexico?
Offer a terse response. 10.42. 